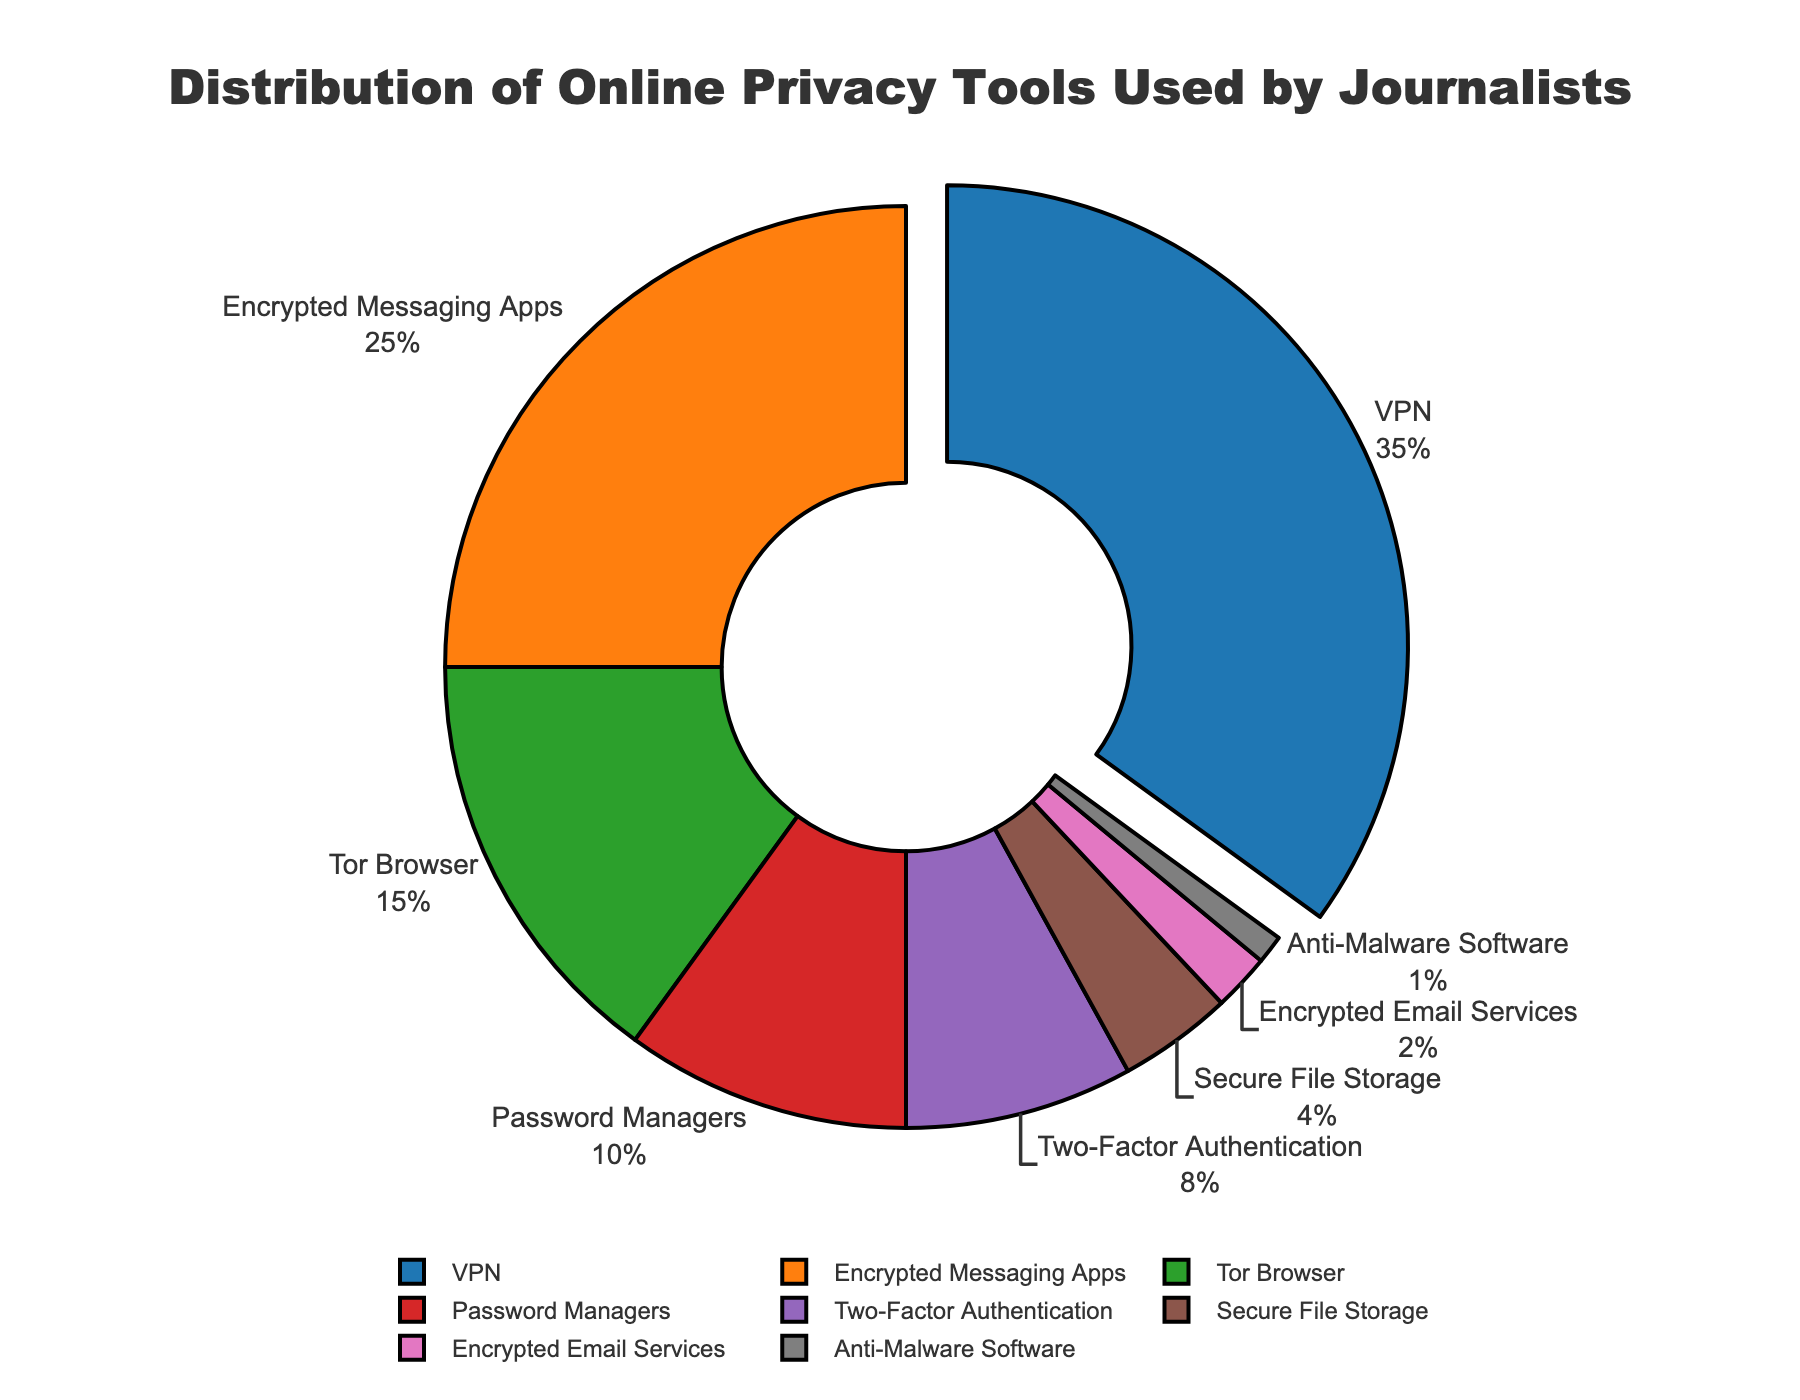What is the most frequently used online privacy tool by journalists? Referring to the pie chart, the segment with the largest area and pulled out from the center is labeled as VPN with a percentage of 35%.
Answer: VPN What percentage of journalists use Encrypted Messaging Apps compared to those using Tor Browser? According to the pie chart, Encrypted Messaging Apps are used by 25% of journalists while Tor Browser is used by 15%. Hence, Encrypted Messaging Apps are used by 10% more journalists.
Answer: 10% What's the total percentage of journalists using either Password Managers or Two-Factor Authentication? From the pie chart, Password Managers account for 10% and Two-Factor Authentication accounts for 8%. Adding these together gives 10% + 8% = 18%.
Answer: 18% Which tool has the least usage among journalists? The smallest segment in the pie chart represents Anti-Malware Software, which has a usage percentage of 1%.
Answer: Anti-Malware Software How many privacy tools are used by less than 10% of journalists? By observing the pie chart, the tools used by less than 10% of journalists are Password Managers (10%), Two-Factor Authentication (8%), Secure File Storage (4%), Encrypted Email Services (2%), and Anti-Malware Software (1%). This adds up to 5 tools.
Answer: 5 Which tool occupies the second-largest portion of the pie chart? The second-largest segment in the pie chart, after VPN, is Encrypted Messaging Apps, occupying 25% of the chart.
Answer: Encrypted Messaging Apps Compare the combined percentage of Secure File Storage, Encrypted Email Services, and Anti-Malware Software to that of Tor Browser. The combined percentage of Secure File Storage (4%), Encrypted Email Services (2%), and Anti-Malware Software (1%) is 4% + 2% + 1% = 7%. Tor Browser alone accounts for 15% which is greater than the combined percentage of these three tools.
Answer: Tor Browser is greater What's the difference in percentage between the usage of VPN and Password Managers by journalists? According to the pie chart, the usage of VPN is 35% and Password Managers is 10%. The difference is 35% - 10% = 25%.
Answer: 25% Is the percentage of journalists using Encrypted Messaging Apps more than double the percentage of those using Secure File Storage? Encrypted Messaging Apps are used by 25% of journalists, while Secure File Storage is used by 4%. Doubling 4% gives 8%, and 25% is indeed more than 8%.
Answer: Yes 